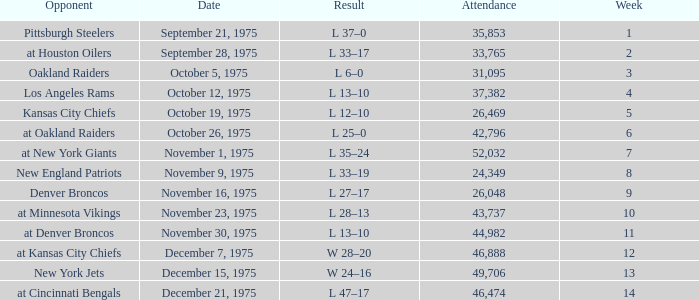What is the highest Week when the opponent was kansas city chiefs, with more than 26,469 in attendance? None. 